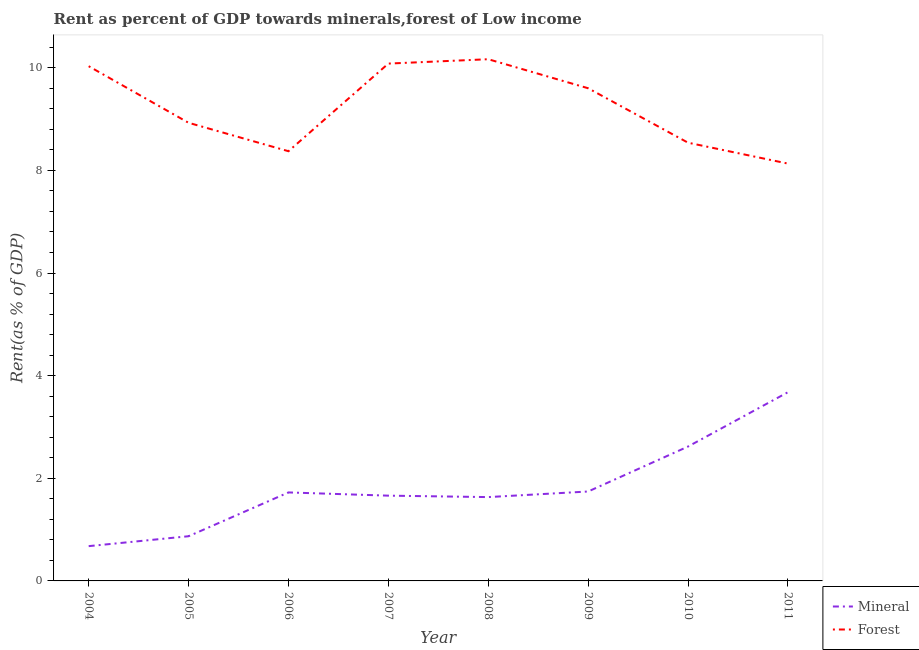How many different coloured lines are there?
Give a very brief answer. 2. What is the mineral rent in 2006?
Your response must be concise. 1.72. Across all years, what is the maximum forest rent?
Your answer should be very brief. 10.17. Across all years, what is the minimum forest rent?
Offer a very short reply. 8.13. What is the total mineral rent in the graph?
Give a very brief answer. 14.61. What is the difference between the mineral rent in 2010 and that in 2011?
Make the answer very short. -1.06. What is the difference between the mineral rent in 2007 and the forest rent in 2005?
Ensure brevity in your answer.  -7.27. What is the average forest rent per year?
Provide a succinct answer. 9.23. In the year 2010, what is the difference between the forest rent and mineral rent?
Make the answer very short. 5.92. What is the ratio of the mineral rent in 2008 to that in 2010?
Your answer should be compact. 0.62. What is the difference between the highest and the second highest mineral rent?
Keep it short and to the point. 1.06. What is the difference between the highest and the lowest forest rent?
Your answer should be very brief. 2.03. In how many years, is the forest rent greater than the average forest rent taken over all years?
Keep it short and to the point. 4. How many lines are there?
Provide a succinct answer. 2. Are the values on the major ticks of Y-axis written in scientific E-notation?
Your answer should be compact. No. Where does the legend appear in the graph?
Offer a very short reply. Bottom right. How many legend labels are there?
Offer a very short reply. 2. What is the title of the graph?
Provide a succinct answer. Rent as percent of GDP towards minerals,forest of Low income. Does "Male labor force" appear as one of the legend labels in the graph?
Offer a very short reply. No. What is the label or title of the Y-axis?
Your answer should be compact. Rent(as % of GDP). What is the Rent(as % of GDP) in Mineral in 2004?
Your answer should be compact. 0.68. What is the Rent(as % of GDP) in Forest in 2004?
Make the answer very short. 10.03. What is the Rent(as % of GDP) of Mineral in 2005?
Give a very brief answer. 0.87. What is the Rent(as % of GDP) of Forest in 2005?
Ensure brevity in your answer.  8.93. What is the Rent(as % of GDP) in Mineral in 2006?
Make the answer very short. 1.72. What is the Rent(as % of GDP) in Forest in 2006?
Your answer should be compact. 8.37. What is the Rent(as % of GDP) in Mineral in 2007?
Ensure brevity in your answer.  1.66. What is the Rent(as % of GDP) in Forest in 2007?
Your answer should be very brief. 10.08. What is the Rent(as % of GDP) of Mineral in 2008?
Keep it short and to the point. 1.63. What is the Rent(as % of GDP) of Forest in 2008?
Your response must be concise. 10.17. What is the Rent(as % of GDP) in Mineral in 2009?
Offer a terse response. 1.74. What is the Rent(as % of GDP) of Forest in 2009?
Ensure brevity in your answer.  9.6. What is the Rent(as % of GDP) of Mineral in 2010?
Keep it short and to the point. 2.62. What is the Rent(as % of GDP) in Forest in 2010?
Provide a short and direct response. 8.54. What is the Rent(as % of GDP) in Mineral in 2011?
Offer a terse response. 3.68. What is the Rent(as % of GDP) of Forest in 2011?
Ensure brevity in your answer.  8.13. Across all years, what is the maximum Rent(as % of GDP) in Mineral?
Give a very brief answer. 3.68. Across all years, what is the maximum Rent(as % of GDP) in Forest?
Ensure brevity in your answer.  10.17. Across all years, what is the minimum Rent(as % of GDP) in Mineral?
Your response must be concise. 0.68. Across all years, what is the minimum Rent(as % of GDP) in Forest?
Your answer should be very brief. 8.13. What is the total Rent(as % of GDP) of Mineral in the graph?
Give a very brief answer. 14.61. What is the total Rent(as % of GDP) in Forest in the graph?
Offer a very short reply. 73.85. What is the difference between the Rent(as % of GDP) in Mineral in 2004 and that in 2005?
Offer a terse response. -0.19. What is the difference between the Rent(as % of GDP) in Forest in 2004 and that in 2005?
Offer a terse response. 1.1. What is the difference between the Rent(as % of GDP) of Mineral in 2004 and that in 2006?
Your answer should be compact. -1.05. What is the difference between the Rent(as % of GDP) in Forest in 2004 and that in 2006?
Ensure brevity in your answer.  1.66. What is the difference between the Rent(as % of GDP) in Mineral in 2004 and that in 2007?
Your answer should be compact. -0.98. What is the difference between the Rent(as % of GDP) in Forest in 2004 and that in 2007?
Ensure brevity in your answer.  -0.05. What is the difference between the Rent(as % of GDP) in Mineral in 2004 and that in 2008?
Your answer should be compact. -0.96. What is the difference between the Rent(as % of GDP) in Forest in 2004 and that in 2008?
Offer a very short reply. -0.14. What is the difference between the Rent(as % of GDP) of Mineral in 2004 and that in 2009?
Provide a short and direct response. -1.06. What is the difference between the Rent(as % of GDP) of Forest in 2004 and that in 2009?
Your answer should be very brief. 0.43. What is the difference between the Rent(as % of GDP) in Mineral in 2004 and that in 2010?
Offer a very short reply. -1.94. What is the difference between the Rent(as % of GDP) of Forest in 2004 and that in 2010?
Your response must be concise. 1.49. What is the difference between the Rent(as % of GDP) in Mineral in 2004 and that in 2011?
Provide a short and direct response. -3. What is the difference between the Rent(as % of GDP) in Forest in 2004 and that in 2011?
Offer a very short reply. 1.9. What is the difference between the Rent(as % of GDP) in Mineral in 2005 and that in 2006?
Your answer should be very brief. -0.85. What is the difference between the Rent(as % of GDP) in Forest in 2005 and that in 2006?
Your answer should be compact. 0.55. What is the difference between the Rent(as % of GDP) of Mineral in 2005 and that in 2007?
Keep it short and to the point. -0.79. What is the difference between the Rent(as % of GDP) in Forest in 2005 and that in 2007?
Keep it short and to the point. -1.15. What is the difference between the Rent(as % of GDP) of Mineral in 2005 and that in 2008?
Make the answer very short. -0.76. What is the difference between the Rent(as % of GDP) in Forest in 2005 and that in 2008?
Give a very brief answer. -1.24. What is the difference between the Rent(as % of GDP) of Mineral in 2005 and that in 2009?
Your answer should be compact. -0.87. What is the difference between the Rent(as % of GDP) in Forest in 2005 and that in 2009?
Give a very brief answer. -0.67. What is the difference between the Rent(as % of GDP) in Mineral in 2005 and that in 2010?
Provide a succinct answer. -1.75. What is the difference between the Rent(as % of GDP) of Forest in 2005 and that in 2010?
Make the answer very short. 0.39. What is the difference between the Rent(as % of GDP) in Mineral in 2005 and that in 2011?
Your answer should be compact. -2.81. What is the difference between the Rent(as % of GDP) in Forest in 2005 and that in 2011?
Keep it short and to the point. 0.8. What is the difference between the Rent(as % of GDP) of Mineral in 2006 and that in 2007?
Offer a very short reply. 0.06. What is the difference between the Rent(as % of GDP) in Forest in 2006 and that in 2007?
Provide a short and direct response. -1.71. What is the difference between the Rent(as % of GDP) of Mineral in 2006 and that in 2008?
Provide a succinct answer. 0.09. What is the difference between the Rent(as % of GDP) in Forest in 2006 and that in 2008?
Ensure brevity in your answer.  -1.79. What is the difference between the Rent(as % of GDP) in Mineral in 2006 and that in 2009?
Your answer should be very brief. -0.02. What is the difference between the Rent(as % of GDP) in Forest in 2006 and that in 2009?
Give a very brief answer. -1.23. What is the difference between the Rent(as % of GDP) in Mineral in 2006 and that in 2010?
Ensure brevity in your answer.  -0.89. What is the difference between the Rent(as % of GDP) of Forest in 2006 and that in 2010?
Give a very brief answer. -0.17. What is the difference between the Rent(as % of GDP) in Mineral in 2006 and that in 2011?
Keep it short and to the point. -1.95. What is the difference between the Rent(as % of GDP) of Forest in 2006 and that in 2011?
Offer a terse response. 0.24. What is the difference between the Rent(as % of GDP) in Mineral in 2007 and that in 2008?
Make the answer very short. 0.03. What is the difference between the Rent(as % of GDP) of Forest in 2007 and that in 2008?
Provide a succinct answer. -0.09. What is the difference between the Rent(as % of GDP) of Mineral in 2007 and that in 2009?
Ensure brevity in your answer.  -0.08. What is the difference between the Rent(as % of GDP) in Forest in 2007 and that in 2009?
Your response must be concise. 0.48. What is the difference between the Rent(as % of GDP) of Mineral in 2007 and that in 2010?
Provide a short and direct response. -0.96. What is the difference between the Rent(as % of GDP) in Forest in 2007 and that in 2010?
Provide a succinct answer. 1.54. What is the difference between the Rent(as % of GDP) of Mineral in 2007 and that in 2011?
Ensure brevity in your answer.  -2.02. What is the difference between the Rent(as % of GDP) in Forest in 2007 and that in 2011?
Your answer should be very brief. 1.95. What is the difference between the Rent(as % of GDP) of Mineral in 2008 and that in 2009?
Ensure brevity in your answer.  -0.11. What is the difference between the Rent(as % of GDP) of Forest in 2008 and that in 2009?
Your answer should be compact. 0.57. What is the difference between the Rent(as % of GDP) of Mineral in 2008 and that in 2010?
Your answer should be compact. -0.98. What is the difference between the Rent(as % of GDP) of Forest in 2008 and that in 2010?
Make the answer very short. 1.63. What is the difference between the Rent(as % of GDP) of Mineral in 2008 and that in 2011?
Offer a terse response. -2.04. What is the difference between the Rent(as % of GDP) in Forest in 2008 and that in 2011?
Ensure brevity in your answer.  2.03. What is the difference between the Rent(as % of GDP) of Mineral in 2009 and that in 2010?
Give a very brief answer. -0.88. What is the difference between the Rent(as % of GDP) of Forest in 2009 and that in 2010?
Your answer should be compact. 1.06. What is the difference between the Rent(as % of GDP) in Mineral in 2009 and that in 2011?
Your answer should be very brief. -1.93. What is the difference between the Rent(as % of GDP) of Forest in 2009 and that in 2011?
Offer a very short reply. 1.47. What is the difference between the Rent(as % of GDP) of Mineral in 2010 and that in 2011?
Ensure brevity in your answer.  -1.06. What is the difference between the Rent(as % of GDP) of Forest in 2010 and that in 2011?
Keep it short and to the point. 0.41. What is the difference between the Rent(as % of GDP) in Mineral in 2004 and the Rent(as % of GDP) in Forest in 2005?
Offer a very short reply. -8.25. What is the difference between the Rent(as % of GDP) in Mineral in 2004 and the Rent(as % of GDP) in Forest in 2006?
Your response must be concise. -7.7. What is the difference between the Rent(as % of GDP) in Mineral in 2004 and the Rent(as % of GDP) in Forest in 2007?
Your answer should be compact. -9.4. What is the difference between the Rent(as % of GDP) in Mineral in 2004 and the Rent(as % of GDP) in Forest in 2008?
Your answer should be compact. -9.49. What is the difference between the Rent(as % of GDP) of Mineral in 2004 and the Rent(as % of GDP) of Forest in 2009?
Your answer should be compact. -8.92. What is the difference between the Rent(as % of GDP) in Mineral in 2004 and the Rent(as % of GDP) in Forest in 2010?
Offer a terse response. -7.86. What is the difference between the Rent(as % of GDP) of Mineral in 2004 and the Rent(as % of GDP) of Forest in 2011?
Ensure brevity in your answer.  -7.46. What is the difference between the Rent(as % of GDP) of Mineral in 2005 and the Rent(as % of GDP) of Forest in 2006?
Your answer should be compact. -7.5. What is the difference between the Rent(as % of GDP) of Mineral in 2005 and the Rent(as % of GDP) of Forest in 2007?
Keep it short and to the point. -9.21. What is the difference between the Rent(as % of GDP) of Mineral in 2005 and the Rent(as % of GDP) of Forest in 2008?
Make the answer very short. -9.3. What is the difference between the Rent(as % of GDP) of Mineral in 2005 and the Rent(as % of GDP) of Forest in 2009?
Provide a short and direct response. -8.73. What is the difference between the Rent(as % of GDP) in Mineral in 2005 and the Rent(as % of GDP) in Forest in 2010?
Provide a short and direct response. -7.67. What is the difference between the Rent(as % of GDP) in Mineral in 2005 and the Rent(as % of GDP) in Forest in 2011?
Offer a terse response. -7.26. What is the difference between the Rent(as % of GDP) of Mineral in 2006 and the Rent(as % of GDP) of Forest in 2007?
Make the answer very short. -8.36. What is the difference between the Rent(as % of GDP) of Mineral in 2006 and the Rent(as % of GDP) of Forest in 2008?
Make the answer very short. -8.44. What is the difference between the Rent(as % of GDP) of Mineral in 2006 and the Rent(as % of GDP) of Forest in 2009?
Ensure brevity in your answer.  -7.88. What is the difference between the Rent(as % of GDP) in Mineral in 2006 and the Rent(as % of GDP) in Forest in 2010?
Offer a terse response. -6.82. What is the difference between the Rent(as % of GDP) of Mineral in 2006 and the Rent(as % of GDP) of Forest in 2011?
Offer a terse response. -6.41. What is the difference between the Rent(as % of GDP) in Mineral in 2007 and the Rent(as % of GDP) in Forest in 2008?
Ensure brevity in your answer.  -8.51. What is the difference between the Rent(as % of GDP) of Mineral in 2007 and the Rent(as % of GDP) of Forest in 2009?
Ensure brevity in your answer.  -7.94. What is the difference between the Rent(as % of GDP) in Mineral in 2007 and the Rent(as % of GDP) in Forest in 2010?
Offer a very short reply. -6.88. What is the difference between the Rent(as % of GDP) of Mineral in 2007 and the Rent(as % of GDP) of Forest in 2011?
Ensure brevity in your answer.  -6.47. What is the difference between the Rent(as % of GDP) in Mineral in 2008 and the Rent(as % of GDP) in Forest in 2009?
Provide a succinct answer. -7.97. What is the difference between the Rent(as % of GDP) in Mineral in 2008 and the Rent(as % of GDP) in Forest in 2010?
Ensure brevity in your answer.  -6.91. What is the difference between the Rent(as % of GDP) in Mineral in 2008 and the Rent(as % of GDP) in Forest in 2011?
Offer a terse response. -6.5. What is the difference between the Rent(as % of GDP) of Mineral in 2009 and the Rent(as % of GDP) of Forest in 2010?
Offer a very short reply. -6.8. What is the difference between the Rent(as % of GDP) of Mineral in 2009 and the Rent(as % of GDP) of Forest in 2011?
Offer a terse response. -6.39. What is the difference between the Rent(as % of GDP) in Mineral in 2010 and the Rent(as % of GDP) in Forest in 2011?
Your answer should be very brief. -5.51. What is the average Rent(as % of GDP) of Mineral per year?
Your response must be concise. 1.83. What is the average Rent(as % of GDP) in Forest per year?
Provide a succinct answer. 9.23. In the year 2004, what is the difference between the Rent(as % of GDP) in Mineral and Rent(as % of GDP) in Forest?
Your response must be concise. -9.35. In the year 2005, what is the difference between the Rent(as % of GDP) of Mineral and Rent(as % of GDP) of Forest?
Keep it short and to the point. -8.06. In the year 2006, what is the difference between the Rent(as % of GDP) of Mineral and Rent(as % of GDP) of Forest?
Your answer should be very brief. -6.65. In the year 2007, what is the difference between the Rent(as % of GDP) in Mineral and Rent(as % of GDP) in Forest?
Offer a terse response. -8.42. In the year 2008, what is the difference between the Rent(as % of GDP) of Mineral and Rent(as % of GDP) of Forest?
Ensure brevity in your answer.  -8.53. In the year 2009, what is the difference between the Rent(as % of GDP) of Mineral and Rent(as % of GDP) of Forest?
Provide a succinct answer. -7.86. In the year 2010, what is the difference between the Rent(as % of GDP) in Mineral and Rent(as % of GDP) in Forest?
Ensure brevity in your answer.  -5.92. In the year 2011, what is the difference between the Rent(as % of GDP) of Mineral and Rent(as % of GDP) of Forest?
Ensure brevity in your answer.  -4.46. What is the ratio of the Rent(as % of GDP) in Mineral in 2004 to that in 2005?
Keep it short and to the point. 0.78. What is the ratio of the Rent(as % of GDP) of Forest in 2004 to that in 2005?
Ensure brevity in your answer.  1.12. What is the ratio of the Rent(as % of GDP) in Mineral in 2004 to that in 2006?
Keep it short and to the point. 0.39. What is the ratio of the Rent(as % of GDP) of Forest in 2004 to that in 2006?
Provide a succinct answer. 1.2. What is the ratio of the Rent(as % of GDP) in Mineral in 2004 to that in 2007?
Your response must be concise. 0.41. What is the ratio of the Rent(as % of GDP) of Mineral in 2004 to that in 2008?
Offer a terse response. 0.41. What is the ratio of the Rent(as % of GDP) of Forest in 2004 to that in 2008?
Provide a succinct answer. 0.99. What is the ratio of the Rent(as % of GDP) in Mineral in 2004 to that in 2009?
Provide a short and direct response. 0.39. What is the ratio of the Rent(as % of GDP) in Forest in 2004 to that in 2009?
Ensure brevity in your answer.  1.04. What is the ratio of the Rent(as % of GDP) in Mineral in 2004 to that in 2010?
Make the answer very short. 0.26. What is the ratio of the Rent(as % of GDP) of Forest in 2004 to that in 2010?
Provide a succinct answer. 1.17. What is the ratio of the Rent(as % of GDP) in Mineral in 2004 to that in 2011?
Your response must be concise. 0.18. What is the ratio of the Rent(as % of GDP) in Forest in 2004 to that in 2011?
Provide a short and direct response. 1.23. What is the ratio of the Rent(as % of GDP) in Mineral in 2005 to that in 2006?
Make the answer very short. 0.51. What is the ratio of the Rent(as % of GDP) in Forest in 2005 to that in 2006?
Offer a very short reply. 1.07. What is the ratio of the Rent(as % of GDP) of Mineral in 2005 to that in 2007?
Ensure brevity in your answer.  0.52. What is the ratio of the Rent(as % of GDP) of Forest in 2005 to that in 2007?
Offer a very short reply. 0.89. What is the ratio of the Rent(as % of GDP) in Mineral in 2005 to that in 2008?
Provide a short and direct response. 0.53. What is the ratio of the Rent(as % of GDP) in Forest in 2005 to that in 2008?
Make the answer very short. 0.88. What is the ratio of the Rent(as % of GDP) of Mineral in 2005 to that in 2009?
Give a very brief answer. 0.5. What is the ratio of the Rent(as % of GDP) of Forest in 2005 to that in 2009?
Ensure brevity in your answer.  0.93. What is the ratio of the Rent(as % of GDP) of Mineral in 2005 to that in 2010?
Your answer should be compact. 0.33. What is the ratio of the Rent(as % of GDP) of Forest in 2005 to that in 2010?
Offer a terse response. 1.05. What is the ratio of the Rent(as % of GDP) of Mineral in 2005 to that in 2011?
Make the answer very short. 0.24. What is the ratio of the Rent(as % of GDP) of Forest in 2005 to that in 2011?
Your response must be concise. 1.1. What is the ratio of the Rent(as % of GDP) in Mineral in 2006 to that in 2007?
Ensure brevity in your answer.  1.04. What is the ratio of the Rent(as % of GDP) of Forest in 2006 to that in 2007?
Provide a succinct answer. 0.83. What is the ratio of the Rent(as % of GDP) of Mineral in 2006 to that in 2008?
Keep it short and to the point. 1.06. What is the ratio of the Rent(as % of GDP) in Forest in 2006 to that in 2008?
Your response must be concise. 0.82. What is the ratio of the Rent(as % of GDP) of Forest in 2006 to that in 2009?
Give a very brief answer. 0.87. What is the ratio of the Rent(as % of GDP) in Mineral in 2006 to that in 2010?
Make the answer very short. 0.66. What is the ratio of the Rent(as % of GDP) of Forest in 2006 to that in 2010?
Offer a terse response. 0.98. What is the ratio of the Rent(as % of GDP) in Mineral in 2006 to that in 2011?
Your answer should be compact. 0.47. What is the ratio of the Rent(as % of GDP) in Forest in 2006 to that in 2011?
Offer a very short reply. 1.03. What is the ratio of the Rent(as % of GDP) in Mineral in 2007 to that in 2008?
Your answer should be very brief. 1.02. What is the ratio of the Rent(as % of GDP) of Forest in 2007 to that in 2008?
Ensure brevity in your answer.  0.99. What is the ratio of the Rent(as % of GDP) of Mineral in 2007 to that in 2009?
Offer a very short reply. 0.95. What is the ratio of the Rent(as % of GDP) of Forest in 2007 to that in 2009?
Provide a succinct answer. 1.05. What is the ratio of the Rent(as % of GDP) of Mineral in 2007 to that in 2010?
Keep it short and to the point. 0.63. What is the ratio of the Rent(as % of GDP) of Forest in 2007 to that in 2010?
Your answer should be very brief. 1.18. What is the ratio of the Rent(as % of GDP) in Mineral in 2007 to that in 2011?
Make the answer very short. 0.45. What is the ratio of the Rent(as % of GDP) of Forest in 2007 to that in 2011?
Your answer should be compact. 1.24. What is the ratio of the Rent(as % of GDP) in Mineral in 2008 to that in 2009?
Provide a short and direct response. 0.94. What is the ratio of the Rent(as % of GDP) in Forest in 2008 to that in 2009?
Offer a very short reply. 1.06. What is the ratio of the Rent(as % of GDP) of Mineral in 2008 to that in 2010?
Make the answer very short. 0.62. What is the ratio of the Rent(as % of GDP) in Forest in 2008 to that in 2010?
Your response must be concise. 1.19. What is the ratio of the Rent(as % of GDP) of Mineral in 2008 to that in 2011?
Offer a terse response. 0.44. What is the ratio of the Rent(as % of GDP) of Forest in 2008 to that in 2011?
Your response must be concise. 1.25. What is the ratio of the Rent(as % of GDP) of Mineral in 2009 to that in 2010?
Provide a short and direct response. 0.67. What is the ratio of the Rent(as % of GDP) in Forest in 2009 to that in 2010?
Your answer should be very brief. 1.12. What is the ratio of the Rent(as % of GDP) of Mineral in 2009 to that in 2011?
Make the answer very short. 0.47. What is the ratio of the Rent(as % of GDP) of Forest in 2009 to that in 2011?
Make the answer very short. 1.18. What is the ratio of the Rent(as % of GDP) in Mineral in 2010 to that in 2011?
Your answer should be very brief. 0.71. What is the difference between the highest and the second highest Rent(as % of GDP) in Mineral?
Provide a succinct answer. 1.06. What is the difference between the highest and the second highest Rent(as % of GDP) of Forest?
Give a very brief answer. 0.09. What is the difference between the highest and the lowest Rent(as % of GDP) of Mineral?
Give a very brief answer. 3. What is the difference between the highest and the lowest Rent(as % of GDP) in Forest?
Keep it short and to the point. 2.03. 